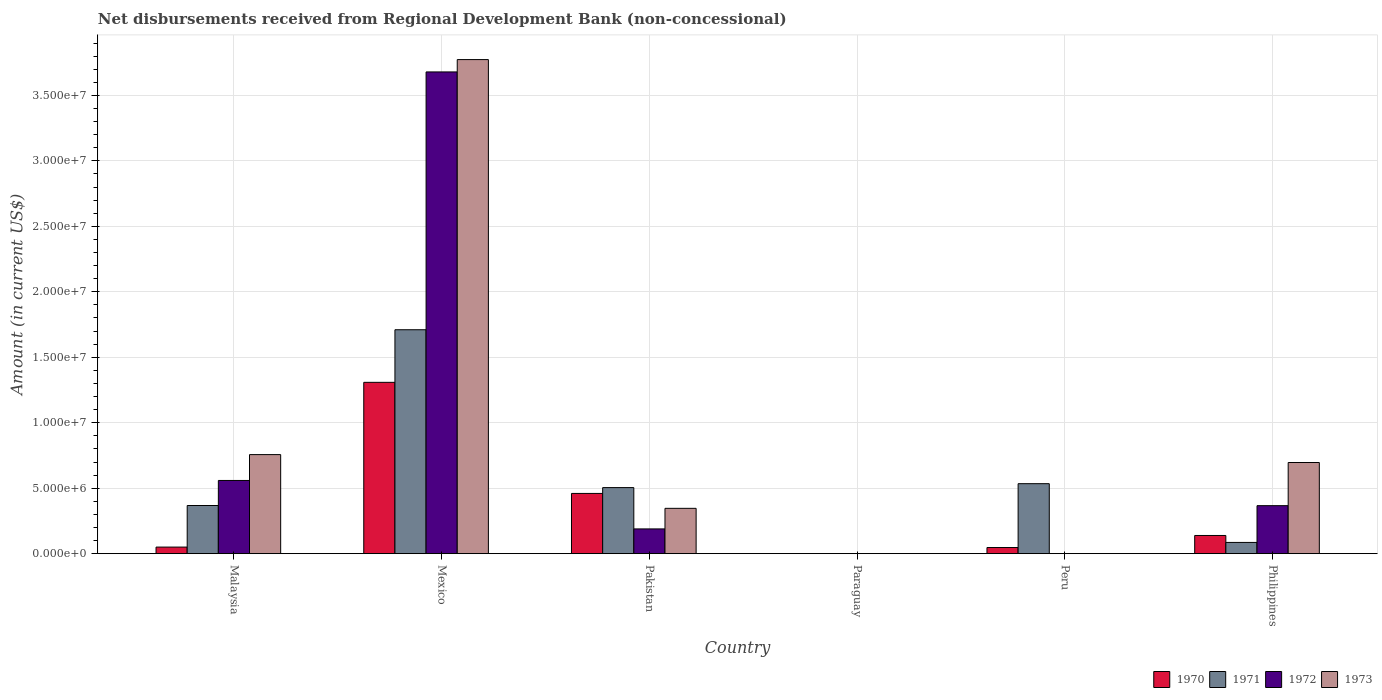How many different coloured bars are there?
Make the answer very short. 4. Are the number of bars on each tick of the X-axis equal?
Your answer should be very brief. No. How many bars are there on the 6th tick from the left?
Your answer should be compact. 4. What is the label of the 4th group of bars from the left?
Ensure brevity in your answer.  Paraguay. In how many cases, is the number of bars for a given country not equal to the number of legend labels?
Offer a very short reply. 2. What is the amount of disbursements received from Regional Development Bank in 1971 in Peru?
Provide a succinct answer. 5.34e+06. Across all countries, what is the maximum amount of disbursements received from Regional Development Bank in 1970?
Provide a succinct answer. 1.31e+07. Across all countries, what is the minimum amount of disbursements received from Regional Development Bank in 1973?
Offer a very short reply. 0. What is the total amount of disbursements received from Regional Development Bank in 1972 in the graph?
Offer a very short reply. 4.79e+07. What is the difference between the amount of disbursements received from Regional Development Bank in 1970 in Malaysia and that in Pakistan?
Ensure brevity in your answer.  -4.10e+06. What is the difference between the amount of disbursements received from Regional Development Bank in 1973 in Mexico and the amount of disbursements received from Regional Development Bank in 1972 in Philippines?
Your answer should be compact. 3.41e+07. What is the average amount of disbursements received from Regional Development Bank in 1970 per country?
Your response must be concise. 3.34e+06. What is the difference between the amount of disbursements received from Regional Development Bank of/in 1973 and amount of disbursements received from Regional Development Bank of/in 1970 in Malaysia?
Ensure brevity in your answer.  7.06e+06. What is the ratio of the amount of disbursements received from Regional Development Bank in 1971 in Malaysia to that in Peru?
Give a very brief answer. 0.69. Is the amount of disbursements received from Regional Development Bank in 1972 in Mexico less than that in Pakistan?
Provide a succinct answer. No. What is the difference between the highest and the second highest amount of disbursements received from Regional Development Bank in 1972?
Your response must be concise. 3.12e+07. What is the difference between the highest and the lowest amount of disbursements received from Regional Development Bank in 1973?
Your answer should be compact. 3.77e+07. In how many countries, is the amount of disbursements received from Regional Development Bank in 1971 greater than the average amount of disbursements received from Regional Development Bank in 1971 taken over all countries?
Make the answer very short. 2. Is the sum of the amount of disbursements received from Regional Development Bank in 1972 in Pakistan and Philippines greater than the maximum amount of disbursements received from Regional Development Bank in 1971 across all countries?
Make the answer very short. No. Are all the bars in the graph horizontal?
Keep it short and to the point. No. Are the values on the major ticks of Y-axis written in scientific E-notation?
Your answer should be very brief. Yes. Does the graph contain any zero values?
Offer a terse response. Yes. Where does the legend appear in the graph?
Provide a succinct answer. Bottom right. What is the title of the graph?
Give a very brief answer. Net disbursements received from Regional Development Bank (non-concessional). Does "1961" appear as one of the legend labels in the graph?
Keep it short and to the point. No. What is the label or title of the X-axis?
Your answer should be very brief. Country. What is the Amount (in current US$) in 1970 in Malaysia?
Make the answer very short. 5.02e+05. What is the Amount (in current US$) of 1971 in Malaysia?
Provide a short and direct response. 3.68e+06. What is the Amount (in current US$) in 1972 in Malaysia?
Make the answer very short. 5.59e+06. What is the Amount (in current US$) in 1973 in Malaysia?
Provide a short and direct response. 7.57e+06. What is the Amount (in current US$) in 1970 in Mexico?
Ensure brevity in your answer.  1.31e+07. What is the Amount (in current US$) in 1971 in Mexico?
Give a very brief answer. 1.71e+07. What is the Amount (in current US$) of 1972 in Mexico?
Ensure brevity in your answer.  3.68e+07. What is the Amount (in current US$) of 1973 in Mexico?
Ensure brevity in your answer.  3.77e+07. What is the Amount (in current US$) of 1970 in Pakistan?
Keep it short and to the point. 4.60e+06. What is the Amount (in current US$) of 1971 in Pakistan?
Your answer should be very brief. 5.04e+06. What is the Amount (in current US$) of 1972 in Pakistan?
Your response must be concise. 1.89e+06. What is the Amount (in current US$) of 1973 in Pakistan?
Your answer should be compact. 3.46e+06. What is the Amount (in current US$) of 1972 in Paraguay?
Make the answer very short. 0. What is the Amount (in current US$) in 1970 in Peru?
Give a very brief answer. 4.68e+05. What is the Amount (in current US$) of 1971 in Peru?
Make the answer very short. 5.34e+06. What is the Amount (in current US$) of 1973 in Peru?
Your response must be concise. 0. What is the Amount (in current US$) of 1970 in Philippines?
Offer a very short reply. 1.39e+06. What is the Amount (in current US$) in 1971 in Philippines?
Your answer should be very brief. 8.58e+05. What is the Amount (in current US$) in 1972 in Philippines?
Keep it short and to the point. 3.67e+06. What is the Amount (in current US$) in 1973 in Philippines?
Your response must be concise. 6.96e+06. Across all countries, what is the maximum Amount (in current US$) in 1970?
Provide a short and direct response. 1.31e+07. Across all countries, what is the maximum Amount (in current US$) of 1971?
Keep it short and to the point. 1.71e+07. Across all countries, what is the maximum Amount (in current US$) in 1972?
Offer a very short reply. 3.68e+07. Across all countries, what is the maximum Amount (in current US$) in 1973?
Your answer should be very brief. 3.77e+07. Across all countries, what is the minimum Amount (in current US$) in 1971?
Make the answer very short. 0. Across all countries, what is the minimum Amount (in current US$) of 1972?
Offer a very short reply. 0. Across all countries, what is the minimum Amount (in current US$) in 1973?
Provide a short and direct response. 0. What is the total Amount (in current US$) of 1970 in the graph?
Offer a very short reply. 2.00e+07. What is the total Amount (in current US$) in 1971 in the graph?
Offer a terse response. 3.20e+07. What is the total Amount (in current US$) of 1972 in the graph?
Offer a terse response. 4.79e+07. What is the total Amount (in current US$) of 1973 in the graph?
Provide a succinct answer. 5.57e+07. What is the difference between the Amount (in current US$) in 1970 in Malaysia and that in Mexico?
Make the answer very short. -1.26e+07. What is the difference between the Amount (in current US$) in 1971 in Malaysia and that in Mexico?
Offer a terse response. -1.34e+07. What is the difference between the Amount (in current US$) of 1972 in Malaysia and that in Mexico?
Offer a very short reply. -3.12e+07. What is the difference between the Amount (in current US$) in 1973 in Malaysia and that in Mexico?
Offer a terse response. -3.02e+07. What is the difference between the Amount (in current US$) of 1970 in Malaysia and that in Pakistan?
Offer a very short reply. -4.10e+06. What is the difference between the Amount (in current US$) in 1971 in Malaysia and that in Pakistan?
Provide a succinct answer. -1.37e+06. What is the difference between the Amount (in current US$) of 1972 in Malaysia and that in Pakistan?
Provide a short and direct response. 3.70e+06. What is the difference between the Amount (in current US$) in 1973 in Malaysia and that in Pakistan?
Provide a succinct answer. 4.10e+06. What is the difference between the Amount (in current US$) of 1970 in Malaysia and that in Peru?
Your answer should be very brief. 3.40e+04. What is the difference between the Amount (in current US$) of 1971 in Malaysia and that in Peru?
Your answer should be very brief. -1.67e+06. What is the difference between the Amount (in current US$) in 1970 in Malaysia and that in Philippines?
Your answer should be very brief. -8.87e+05. What is the difference between the Amount (in current US$) in 1971 in Malaysia and that in Philippines?
Offer a very short reply. 2.82e+06. What is the difference between the Amount (in current US$) of 1972 in Malaysia and that in Philippines?
Provide a short and direct response. 1.92e+06. What is the difference between the Amount (in current US$) of 1973 in Malaysia and that in Philippines?
Your answer should be compact. 6.04e+05. What is the difference between the Amount (in current US$) in 1970 in Mexico and that in Pakistan?
Provide a short and direct response. 8.48e+06. What is the difference between the Amount (in current US$) of 1971 in Mexico and that in Pakistan?
Give a very brief answer. 1.21e+07. What is the difference between the Amount (in current US$) of 1972 in Mexico and that in Pakistan?
Your answer should be compact. 3.49e+07. What is the difference between the Amount (in current US$) of 1973 in Mexico and that in Pakistan?
Keep it short and to the point. 3.43e+07. What is the difference between the Amount (in current US$) in 1970 in Mexico and that in Peru?
Make the answer very short. 1.26e+07. What is the difference between the Amount (in current US$) in 1971 in Mexico and that in Peru?
Your answer should be very brief. 1.18e+07. What is the difference between the Amount (in current US$) of 1970 in Mexico and that in Philippines?
Offer a terse response. 1.17e+07. What is the difference between the Amount (in current US$) of 1971 in Mexico and that in Philippines?
Offer a very short reply. 1.62e+07. What is the difference between the Amount (in current US$) of 1972 in Mexico and that in Philippines?
Give a very brief answer. 3.31e+07. What is the difference between the Amount (in current US$) in 1973 in Mexico and that in Philippines?
Your response must be concise. 3.08e+07. What is the difference between the Amount (in current US$) in 1970 in Pakistan and that in Peru?
Your response must be concise. 4.13e+06. What is the difference between the Amount (in current US$) of 1971 in Pakistan and that in Peru?
Keep it short and to the point. -3.00e+05. What is the difference between the Amount (in current US$) in 1970 in Pakistan and that in Philippines?
Offer a terse response. 3.21e+06. What is the difference between the Amount (in current US$) in 1971 in Pakistan and that in Philippines?
Your response must be concise. 4.19e+06. What is the difference between the Amount (in current US$) in 1972 in Pakistan and that in Philippines?
Ensure brevity in your answer.  -1.78e+06. What is the difference between the Amount (in current US$) of 1973 in Pakistan and that in Philippines?
Offer a terse response. -3.50e+06. What is the difference between the Amount (in current US$) of 1970 in Peru and that in Philippines?
Your answer should be compact. -9.21e+05. What is the difference between the Amount (in current US$) in 1971 in Peru and that in Philippines?
Your answer should be compact. 4.49e+06. What is the difference between the Amount (in current US$) in 1970 in Malaysia and the Amount (in current US$) in 1971 in Mexico?
Provide a short and direct response. -1.66e+07. What is the difference between the Amount (in current US$) in 1970 in Malaysia and the Amount (in current US$) in 1972 in Mexico?
Offer a very short reply. -3.63e+07. What is the difference between the Amount (in current US$) of 1970 in Malaysia and the Amount (in current US$) of 1973 in Mexico?
Make the answer very short. -3.72e+07. What is the difference between the Amount (in current US$) of 1971 in Malaysia and the Amount (in current US$) of 1972 in Mexico?
Give a very brief answer. -3.31e+07. What is the difference between the Amount (in current US$) of 1971 in Malaysia and the Amount (in current US$) of 1973 in Mexico?
Ensure brevity in your answer.  -3.41e+07. What is the difference between the Amount (in current US$) in 1972 in Malaysia and the Amount (in current US$) in 1973 in Mexico?
Keep it short and to the point. -3.21e+07. What is the difference between the Amount (in current US$) of 1970 in Malaysia and the Amount (in current US$) of 1971 in Pakistan?
Provide a short and direct response. -4.54e+06. What is the difference between the Amount (in current US$) of 1970 in Malaysia and the Amount (in current US$) of 1972 in Pakistan?
Provide a short and direct response. -1.39e+06. What is the difference between the Amount (in current US$) in 1970 in Malaysia and the Amount (in current US$) in 1973 in Pakistan?
Your answer should be compact. -2.96e+06. What is the difference between the Amount (in current US$) in 1971 in Malaysia and the Amount (in current US$) in 1972 in Pakistan?
Provide a short and direct response. 1.79e+06. What is the difference between the Amount (in current US$) of 1971 in Malaysia and the Amount (in current US$) of 1973 in Pakistan?
Give a very brief answer. 2.16e+05. What is the difference between the Amount (in current US$) of 1972 in Malaysia and the Amount (in current US$) of 1973 in Pakistan?
Offer a terse response. 2.13e+06. What is the difference between the Amount (in current US$) of 1970 in Malaysia and the Amount (in current US$) of 1971 in Peru?
Provide a short and direct response. -4.84e+06. What is the difference between the Amount (in current US$) of 1970 in Malaysia and the Amount (in current US$) of 1971 in Philippines?
Your answer should be compact. -3.56e+05. What is the difference between the Amount (in current US$) in 1970 in Malaysia and the Amount (in current US$) in 1972 in Philippines?
Provide a succinct answer. -3.16e+06. What is the difference between the Amount (in current US$) in 1970 in Malaysia and the Amount (in current US$) in 1973 in Philippines?
Provide a short and direct response. -6.46e+06. What is the difference between the Amount (in current US$) in 1971 in Malaysia and the Amount (in current US$) in 1972 in Philippines?
Your answer should be compact. 1.10e+04. What is the difference between the Amount (in current US$) of 1971 in Malaysia and the Amount (in current US$) of 1973 in Philippines?
Provide a short and direct response. -3.28e+06. What is the difference between the Amount (in current US$) in 1972 in Malaysia and the Amount (in current US$) in 1973 in Philippines?
Offer a terse response. -1.37e+06. What is the difference between the Amount (in current US$) in 1970 in Mexico and the Amount (in current US$) in 1971 in Pakistan?
Your answer should be very brief. 8.04e+06. What is the difference between the Amount (in current US$) in 1970 in Mexico and the Amount (in current US$) in 1972 in Pakistan?
Your answer should be very brief. 1.12e+07. What is the difference between the Amount (in current US$) of 1970 in Mexico and the Amount (in current US$) of 1973 in Pakistan?
Provide a short and direct response. 9.62e+06. What is the difference between the Amount (in current US$) in 1971 in Mexico and the Amount (in current US$) in 1972 in Pakistan?
Keep it short and to the point. 1.52e+07. What is the difference between the Amount (in current US$) of 1971 in Mexico and the Amount (in current US$) of 1973 in Pakistan?
Your answer should be very brief. 1.36e+07. What is the difference between the Amount (in current US$) of 1972 in Mexico and the Amount (in current US$) of 1973 in Pakistan?
Ensure brevity in your answer.  3.33e+07. What is the difference between the Amount (in current US$) in 1970 in Mexico and the Amount (in current US$) in 1971 in Peru?
Your answer should be very brief. 7.74e+06. What is the difference between the Amount (in current US$) in 1970 in Mexico and the Amount (in current US$) in 1971 in Philippines?
Your answer should be compact. 1.22e+07. What is the difference between the Amount (in current US$) of 1970 in Mexico and the Amount (in current US$) of 1972 in Philippines?
Offer a terse response. 9.42e+06. What is the difference between the Amount (in current US$) in 1970 in Mexico and the Amount (in current US$) in 1973 in Philippines?
Provide a succinct answer. 6.12e+06. What is the difference between the Amount (in current US$) of 1971 in Mexico and the Amount (in current US$) of 1972 in Philippines?
Make the answer very short. 1.34e+07. What is the difference between the Amount (in current US$) in 1971 in Mexico and the Amount (in current US$) in 1973 in Philippines?
Ensure brevity in your answer.  1.01e+07. What is the difference between the Amount (in current US$) of 1972 in Mexico and the Amount (in current US$) of 1973 in Philippines?
Make the answer very short. 2.98e+07. What is the difference between the Amount (in current US$) of 1970 in Pakistan and the Amount (in current US$) of 1971 in Peru?
Make the answer very short. -7.45e+05. What is the difference between the Amount (in current US$) in 1970 in Pakistan and the Amount (in current US$) in 1971 in Philippines?
Your answer should be compact. 3.74e+06. What is the difference between the Amount (in current US$) of 1970 in Pakistan and the Amount (in current US$) of 1972 in Philippines?
Provide a succinct answer. 9.34e+05. What is the difference between the Amount (in current US$) of 1970 in Pakistan and the Amount (in current US$) of 1973 in Philippines?
Offer a terse response. -2.36e+06. What is the difference between the Amount (in current US$) in 1971 in Pakistan and the Amount (in current US$) in 1972 in Philippines?
Your answer should be compact. 1.38e+06. What is the difference between the Amount (in current US$) in 1971 in Pakistan and the Amount (in current US$) in 1973 in Philippines?
Your response must be concise. -1.92e+06. What is the difference between the Amount (in current US$) in 1972 in Pakistan and the Amount (in current US$) in 1973 in Philippines?
Keep it short and to the point. -5.07e+06. What is the difference between the Amount (in current US$) of 1970 in Peru and the Amount (in current US$) of 1971 in Philippines?
Ensure brevity in your answer.  -3.90e+05. What is the difference between the Amount (in current US$) of 1970 in Peru and the Amount (in current US$) of 1972 in Philippines?
Offer a very short reply. -3.20e+06. What is the difference between the Amount (in current US$) of 1970 in Peru and the Amount (in current US$) of 1973 in Philippines?
Offer a terse response. -6.49e+06. What is the difference between the Amount (in current US$) of 1971 in Peru and the Amount (in current US$) of 1972 in Philippines?
Keep it short and to the point. 1.68e+06. What is the difference between the Amount (in current US$) in 1971 in Peru and the Amount (in current US$) in 1973 in Philippines?
Your answer should be very brief. -1.62e+06. What is the average Amount (in current US$) in 1970 per country?
Your answer should be very brief. 3.34e+06. What is the average Amount (in current US$) in 1971 per country?
Your answer should be very brief. 5.34e+06. What is the average Amount (in current US$) of 1972 per country?
Offer a very short reply. 7.99e+06. What is the average Amount (in current US$) in 1973 per country?
Your answer should be very brief. 9.29e+06. What is the difference between the Amount (in current US$) of 1970 and Amount (in current US$) of 1971 in Malaysia?
Your response must be concise. -3.18e+06. What is the difference between the Amount (in current US$) in 1970 and Amount (in current US$) in 1972 in Malaysia?
Keep it short and to the point. -5.09e+06. What is the difference between the Amount (in current US$) in 1970 and Amount (in current US$) in 1973 in Malaysia?
Give a very brief answer. -7.06e+06. What is the difference between the Amount (in current US$) in 1971 and Amount (in current US$) in 1972 in Malaysia?
Offer a terse response. -1.91e+06. What is the difference between the Amount (in current US$) in 1971 and Amount (in current US$) in 1973 in Malaysia?
Provide a succinct answer. -3.89e+06. What is the difference between the Amount (in current US$) in 1972 and Amount (in current US$) in 1973 in Malaysia?
Your response must be concise. -1.98e+06. What is the difference between the Amount (in current US$) in 1970 and Amount (in current US$) in 1971 in Mexico?
Provide a succinct answer. -4.02e+06. What is the difference between the Amount (in current US$) in 1970 and Amount (in current US$) in 1972 in Mexico?
Your answer should be very brief. -2.37e+07. What is the difference between the Amount (in current US$) in 1970 and Amount (in current US$) in 1973 in Mexico?
Your response must be concise. -2.46e+07. What is the difference between the Amount (in current US$) in 1971 and Amount (in current US$) in 1972 in Mexico?
Provide a succinct answer. -1.97e+07. What is the difference between the Amount (in current US$) of 1971 and Amount (in current US$) of 1973 in Mexico?
Provide a short and direct response. -2.06e+07. What is the difference between the Amount (in current US$) in 1972 and Amount (in current US$) in 1973 in Mexico?
Offer a very short reply. -9.43e+05. What is the difference between the Amount (in current US$) in 1970 and Amount (in current US$) in 1971 in Pakistan?
Your response must be concise. -4.45e+05. What is the difference between the Amount (in current US$) of 1970 and Amount (in current US$) of 1972 in Pakistan?
Provide a succinct answer. 2.71e+06. What is the difference between the Amount (in current US$) in 1970 and Amount (in current US$) in 1973 in Pakistan?
Provide a succinct answer. 1.14e+06. What is the difference between the Amount (in current US$) in 1971 and Amount (in current US$) in 1972 in Pakistan?
Your answer should be very brief. 3.16e+06. What is the difference between the Amount (in current US$) in 1971 and Amount (in current US$) in 1973 in Pakistan?
Your answer should be very brief. 1.58e+06. What is the difference between the Amount (in current US$) of 1972 and Amount (in current US$) of 1973 in Pakistan?
Offer a very short reply. -1.57e+06. What is the difference between the Amount (in current US$) of 1970 and Amount (in current US$) of 1971 in Peru?
Your response must be concise. -4.88e+06. What is the difference between the Amount (in current US$) in 1970 and Amount (in current US$) in 1971 in Philippines?
Provide a short and direct response. 5.31e+05. What is the difference between the Amount (in current US$) in 1970 and Amount (in current US$) in 1972 in Philippines?
Offer a very short reply. -2.28e+06. What is the difference between the Amount (in current US$) of 1970 and Amount (in current US$) of 1973 in Philippines?
Give a very brief answer. -5.57e+06. What is the difference between the Amount (in current US$) of 1971 and Amount (in current US$) of 1972 in Philippines?
Provide a succinct answer. -2.81e+06. What is the difference between the Amount (in current US$) of 1971 and Amount (in current US$) of 1973 in Philippines?
Offer a very short reply. -6.10e+06. What is the difference between the Amount (in current US$) in 1972 and Amount (in current US$) in 1973 in Philippines?
Offer a terse response. -3.30e+06. What is the ratio of the Amount (in current US$) in 1970 in Malaysia to that in Mexico?
Give a very brief answer. 0.04. What is the ratio of the Amount (in current US$) of 1971 in Malaysia to that in Mexico?
Give a very brief answer. 0.21. What is the ratio of the Amount (in current US$) of 1972 in Malaysia to that in Mexico?
Provide a short and direct response. 0.15. What is the ratio of the Amount (in current US$) of 1973 in Malaysia to that in Mexico?
Offer a very short reply. 0.2. What is the ratio of the Amount (in current US$) of 1970 in Malaysia to that in Pakistan?
Keep it short and to the point. 0.11. What is the ratio of the Amount (in current US$) of 1971 in Malaysia to that in Pakistan?
Provide a short and direct response. 0.73. What is the ratio of the Amount (in current US$) of 1972 in Malaysia to that in Pakistan?
Make the answer very short. 2.96. What is the ratio of the Amount (in current US$) in 1973 in Malaysia to that in Pakistan?
Provide a short and direct response. 2.19. What is the ratio of the Amount (in current US$) of 1970 in Malaysia to that in Peru?
Ensure brevity in your answer.  1.07. What is the ratio of the Amount (in current US$) in 1971 in Malaysia to that in Peru?
Make the answer very short. 0.69. What is the ratio of the Amount (in current US$) of 1970 in Malaysia to that in Philippines?
Provide a succinct answer. 0.36. What is the ratio of the Amount (in current US$) of 1971 in Malaysia to that in Philippines?
Your answer should be compact. 4.29. What is the ratio of the Amount (in current US$) in 1972 in Malaysia to that in Philippines?
Make the answer very short. 1.52. What is the ratio of the Amount (in current US$) in 1973 in Malaysia to that in Philippines?
Make the answer very short. 1.09. What is the ratio of the Amount (in current US$) in 1970 in Mexico to that in Pakistan?
Give a very brief answer. 2.84. What is the ratio of the Amount (in current US$) in 1971 in Mexico to that in Pakistan?
Your response must be concise. 3.39. What is the ratio of the Amount (in current US$) of 1972 in Mexico to that in Pakistan?
Provide a succinct answer. 19.47. What is the ratio of the Amount (in current US$) of 1973 in Mexico to that in Pakistan?
Ensure brevity in your answer.  10.9. What is the ratio of the Amount (in current US$) of 1970 in Mexico to that in Peru?
Give a very brief answer. 27.96. What is the ratio of the Amount (in current US$) in 1971 in Mexico to that in Peru?
Provide a short and direct response. 3.2. What is the ratio of the Amount (in current US$) in 1970 in Mexico to that in Philippines?
Your answer should be very brief. 9.42. What is the ratio of the Amount (in current US$) in 1971 in Mexico to that in Philippines?
Offer a terse response. 19.93. What is the ratio of the Amount (in current US$) in 1972 in Mexico to that in Philippines?
Provide a succinct answer. 10.04. What is the ratio of the Amount (in current US$) of 1973 in Mexico to that in Philippines?
Keep it short and to the point. 5.42. What is the ratio of the Amount (in current US$) in 1970 in Pakistan to that in Peru?
Your response must be concise. 9.83. What is the ratio of the Amount (in current US$) in 1971 in Pakistan to that in Peru?
Provide a short and direct response. 0.94. What is the ratio of the Amount (in current US$) in 1970 in Pakistan to that in Philippines?
Offer a terse response. 3.31. What is the ratio of the Amount (in current US$) of 1971 in Pakistan to that in Philippines?
Your response must be concise. 5.88. What is the ratio of the Amount (in current US$) of 1972 in Pakistan to that in Philippines?
Your answer should be compact. 0.52. What is the ratio of the Amount (in current US$) in 1973 in Pakistan to that in Philippines?
Make the answer very short. 0.5. What is the ratio of the Amount (in current US$) of 1970 in Peru to that in Philippines?
Your answer should be compact. 0.34. What is the ratio of the Amount (in current US$) of 1971 in Peru to that in Philippines?
Keep it short and to the point. 6.23. What is the difference between the highest and the second highest Amount (in current US$) in 1970?
Provide a succinct answer. 8.48e+06. What is the difference between the highest and the second highest Amount (in current US$) in 1971?
Your response must be concise. 1.18e+07. What is the difference between the highest and the second highest Amount (in current US$) of 1972?
Your answer should be compact. 3.12e+07. What is the difference between the highest and the second highest Amount (in current US$) in 1973?
Give a very brief answer. 3.02e+07. What is the difference between the highest and the lowest Amount (in current US$) in 1970?
Keep it short and to the point. 1.31e+07. What is the difference between the highest and the lowest Amount (in current US$) in 1971?
Give a very brief answer. 1.71e+07. What is the difference between the highest and the lowest Amount (in current US$) in 1972?
Offer a terse response. 3.68e+07. What is the difference between the highest and the lowest Amount (in current US$) in 1973?
Keep it short and to the point. 3.77e+07. 